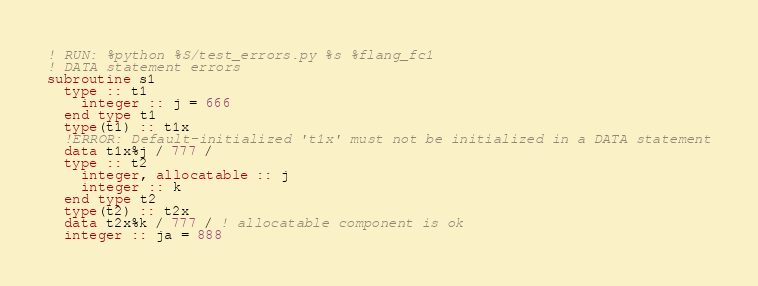<code> <loc_0><loc_0><loc_500><loc_500><_FORTRAN_>! RUN: %python %S/test_errors.py %s %flang_fc1
! DATA statement errors
subroutine s1
  type :: t1
    integer :: j = 666
  end type t1
  type(t1) :: t1x
  !ERROR: Default-initialized 't1x' must not be initialized in a DATA statement
  data t1x%j / 777 /
  type :: t2
    integer, allocatable :: j
    integer :: k
  end type t2
  type(t2) :: t2x
  data t2x%k / 777 / ! allocatable component is ok
  integer :: ja = 888</code> 